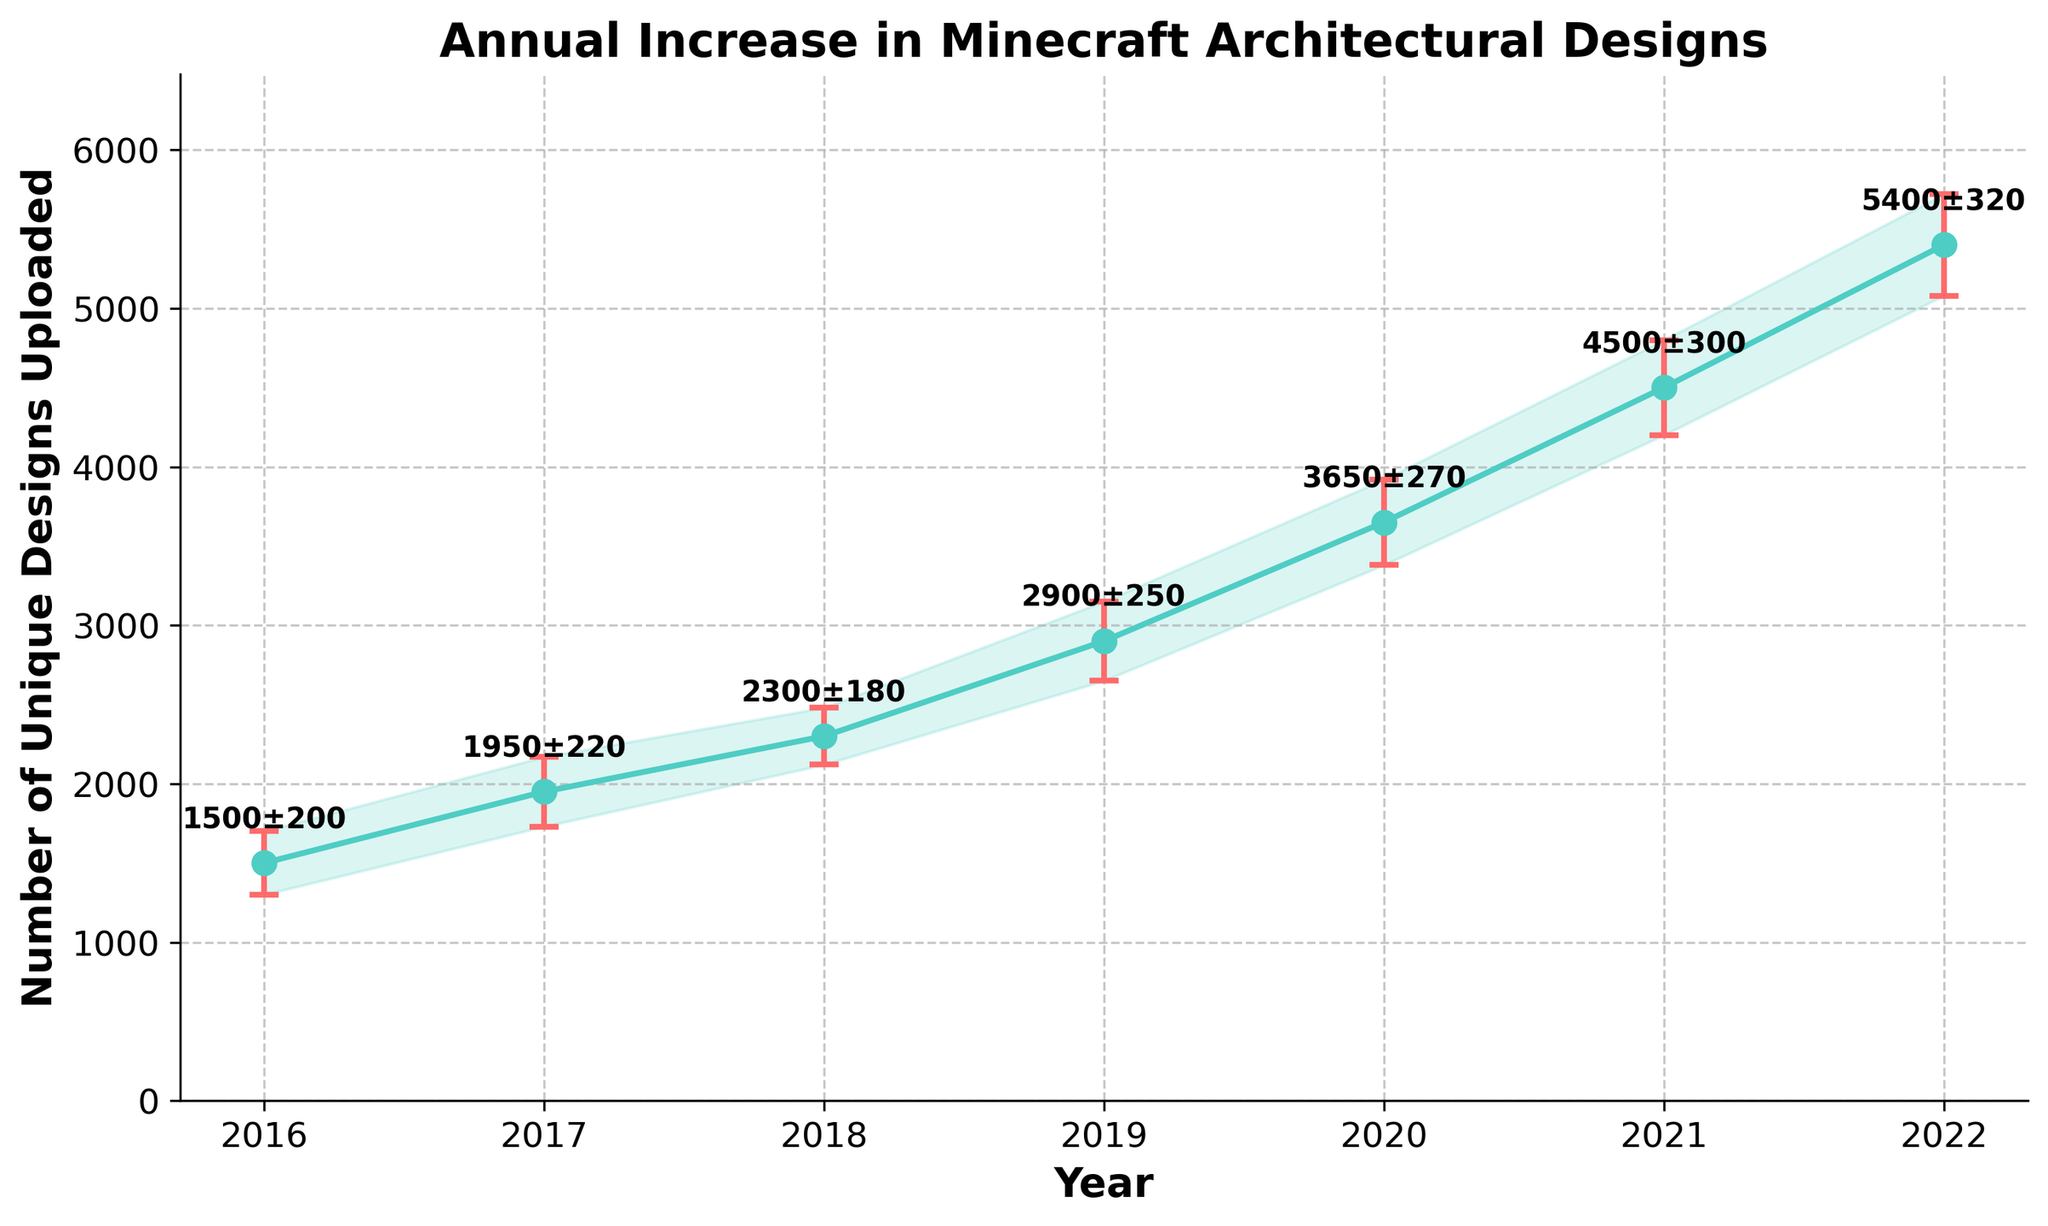How many years of data are represented in the figure? Count the number of unique years shown on the x-axis. The years range from 2016 to 2022, which gives 7 data points.
Answer: 7 What is the range of years covered by this data? Identify the first year and the last year on the x-axis. The data starts at 2016 and ends at 2022.
Answer: 2016 to 2022 Which year saw the highest number of unique designs uploaded? Locate the highest point on the line plot. The highest point corresponds to the year 2022 with around 5400 designs uploaded.
Answer: 2022 What is the approximate number of unique designs uploaded in 2020? Find the data point on the line plot corresponding to the year 2020. The plot shows approximately 3650 designs uploaded in 2020.
Answer: 3650 What was the average annual increase in the number of unique designs uploaded from 2016 to 2022? Calculate the difference in designs uploaded between 2022 and 2016 and divide by the number of years. ((5400 - 1500) / (2022 - 2016)) = (3900 / 6) ≈ 650 designs per year.
Answer: 650 Which year had the largest error margin in the number of designs uploaded? Observe which error bar is the longest. The year 2022 has the largest error margin, with an error of 320 designs.
Answer: 2022 What was the total number of designs uploaded in 2018 and 2019 combined? Add the number of designs uploaded in 2018 and 2019. (2300 + 2900) = 5200 designs.
Answer: 5200 By how much did the number of designs uploaded increase from 2019 to 2020? Subtract the number of designs uploaded in 2019 from the number in 2020. (3650 - 2900) = 750 designs.
Answer: 750 Which two consecutive years saw the smallest increase in the number of designs uploaded? Compare the year-over-year increases. Find the pair with the smallest difference. The smallest increase is from 2017 to 2018 with an increase of (2300 - 1950) = 350 designs.
Answer: 2017 to 2018 